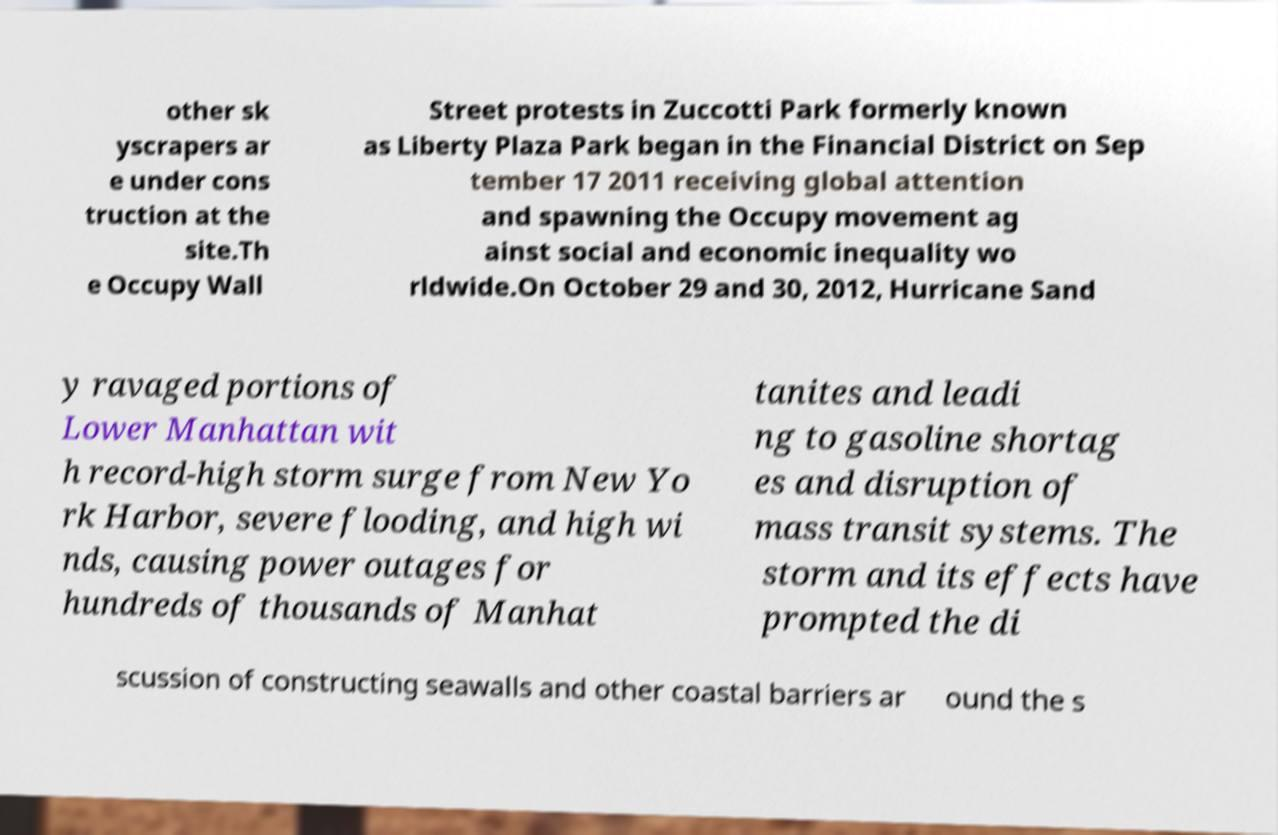For documentation purposes, I need the text within this image transcribed. Could you provide that? other sk yscrapers ar e under cons truction at the site.Th e Occupy Wall Street protests in Zuccotti Park formerly known as Liberty Plaza Park began in the Financial District on Sep tember 17 2011 receiving global attention and spawning the Occupy movement ag ainst social and economic inequality wo rldwide.On October 29 and 30, 2012, Hurricane Sand y ravaged portions of Lower Manhattan wit h record-high storm surge from New Yo rk Harbor, severe flooding, and high wi nds, causing power outages for hundreds of thousands of Manhat tanites and leadi ng to gasoline shortag es and disruption of mass transit systems. The storm and its effects have prompted the di scussion of constructing seawalls and other coastal barriers ar ound the s 